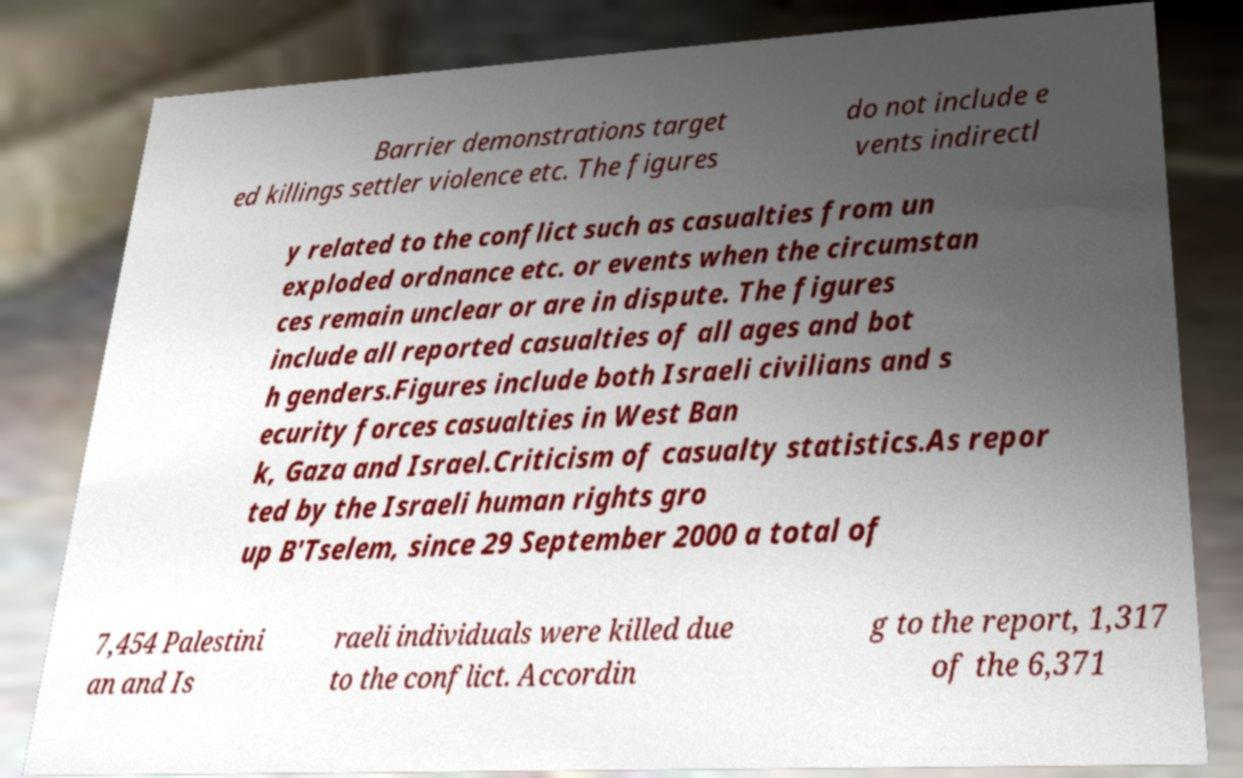I need the written content from this picture converted into text. Can you do that? Barrier demonstrations target ed killings settler violence etc. The figures do not include e vents indirectl y related to the conflict such as casualties from un exploded ordnance etc. or events when the circumstan ces remain unclear or are in dispute. The figures include all reported casualties of all ages and bot h genders.Figures include both Israeli civilians and s ecurity forces casualties in West Ban k, Gaza and Israel.Criticism of casualty statistics.As repor ted by the Israeli human rights gro up B'Tselem, since 29 September 2000 a total of 7,454 Palestini an and Is raeli individuals were killed due to the conflict. Accordin g to the report, 1,317 of the 6,371 